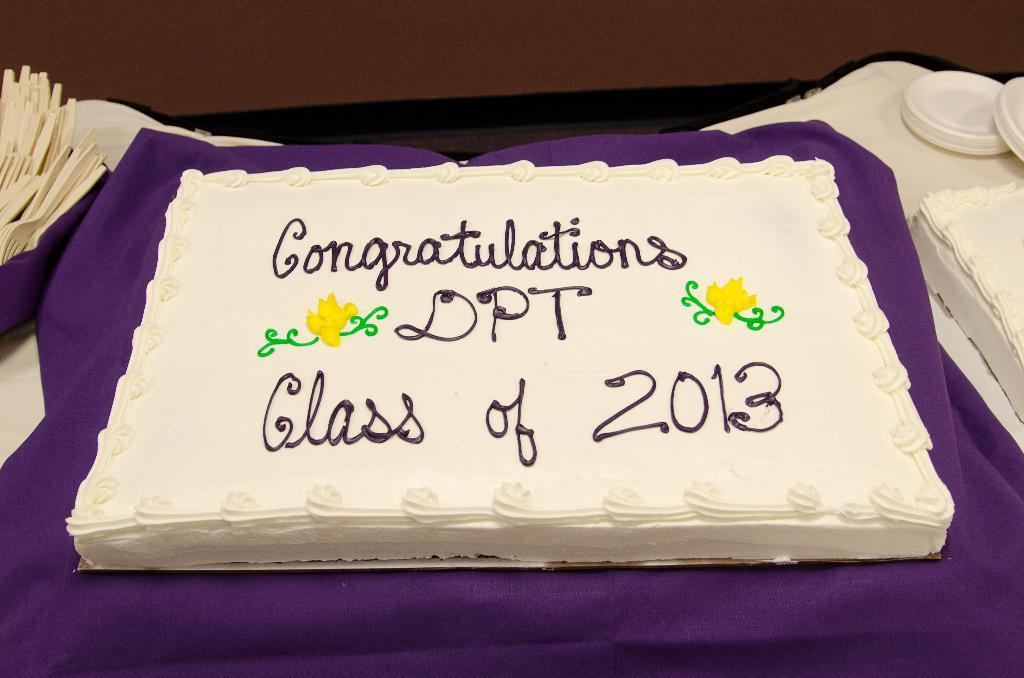What is the main subject in the center of the image? There is a cake in the center of the image. What is the cake placed on? The cake is on a cloth. Where are the spoons located in the image? The spoons are on the left side of the image. What sound can be heard coming from the chickens in the image? There are no chickens present in the image, so no sound can be heard from them. 